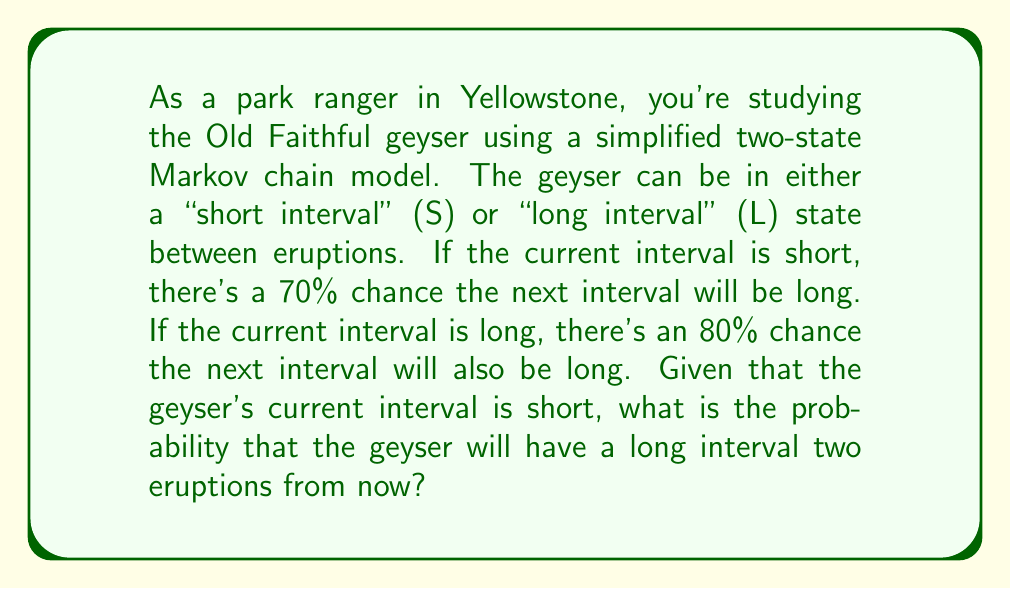Could you help me with this problem? Let's approach this step-by-step using the Markov chain model:

1) First, let's define our transition matrix P:

   $$P = \begin{bmatrix}
   0.3 & 0.7 \\
   0.2 & 0.8
   \end{bmatrix}$$

   where the rows represent the current state (S, L) and the columns represent the next state (S, L).

2) We want to find the probability of being in state L after two transitions, starting from state S.

3) To do this, we need to calculate $P^2$:

   $$P^2 = P \times P = \begin{bmatrix}
   0.3 & 0.7 \\
   0.2 & 0.8
   \end{bmatrix} \times \begin{bmatrix}
   0.3 & 0.7 \\
   0.2 & 0.8
   \end{bmatrix}$$

4) Multiplying these matrices:

   $$P^2 = \begin{bmatrix}
   (0.3)(0.3) + (0.7)(0.2) & (0.3)(0.7) + (0.7)(0.8) \\
   (0.2)(0.3) + (0.8)(0.2) & (0.2)(0.7) + (0.8)(0.8)
   \end{bmatrix}$$

5) Simplifying:

   $$P^2 = \begin{bmatrix}
   0.23 & 0.77 \\
   0.22 & 0.78
   \end{bmatrix}$$

6) The probability we're looking for is in the first row (since we start in state S) and second column (since we want to end in state L) of $P^2$.

Therefore, the probability of being in a long interval state two eruptions from now, given that the current interval is short, is 0.77 or 77%.
Answer: 0.77 